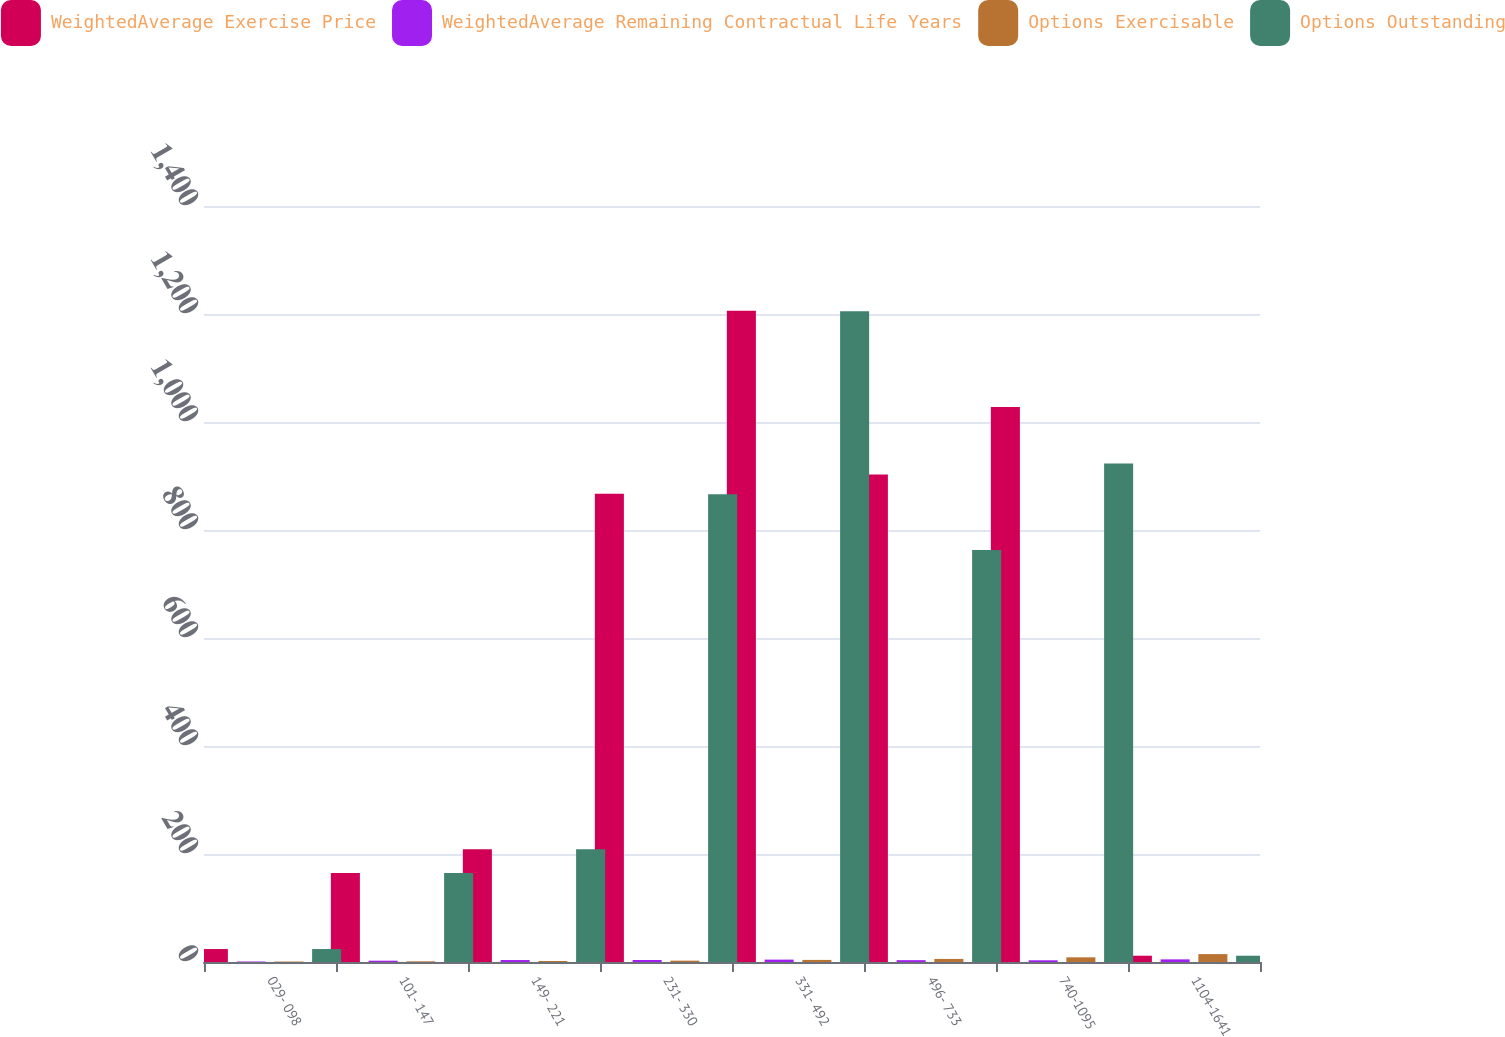Convert chart to OTSL. <chart><loc_0><loc_0><loc_500><loc_500><stacked_bar_chart><ecel><fcel>029- 098<fcel>101- 147<fcel>149- 221<fcel>231- 330<fcel>331- 492<fcel>496- 733<fcel>740-1095<fcel>1104-1641<nl><fcel>WeightedAverage Exercise Price<fcel>24<fcel>165<fcel>209<fcel>867<fcel>1206<fcel>903<fcel>1028<fcel>11.645<nl><fcel>WeightedAverage Remaining Contractual Life Years<fcel>0.9<fcel>2.42<fcel>3.63<fcel>3.67<fcel>4.43<fcel>3.4<fcel>3.2<fcel>4.88<nl><fcel>Options Exercisable<fcel>0.84<fcel>1.26<fcel>1.87<fcel>2.49<fcel>3.86<fcel>5.66<fcel>8.67<fcel>14.62<nl><fcel>Options Outstanding<fcel>24<fcel>165<fcel>209<fcel>866<fcel>1205<fcel>763<fcel>923<fcel>11.645<nl></chart> 